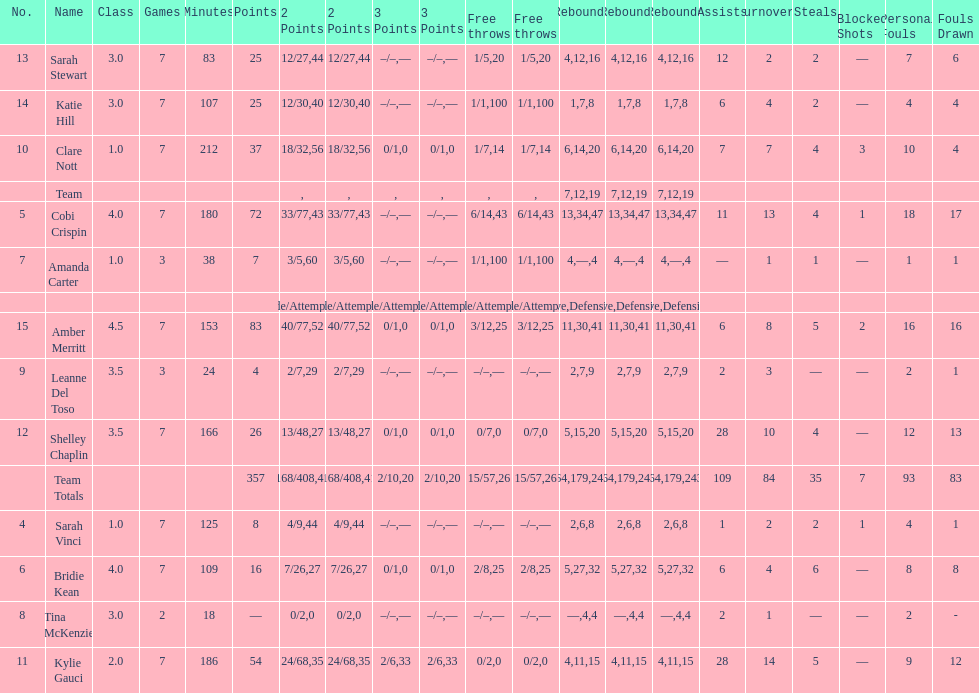After playing seven games, how many players individual points were above 30? 4. 